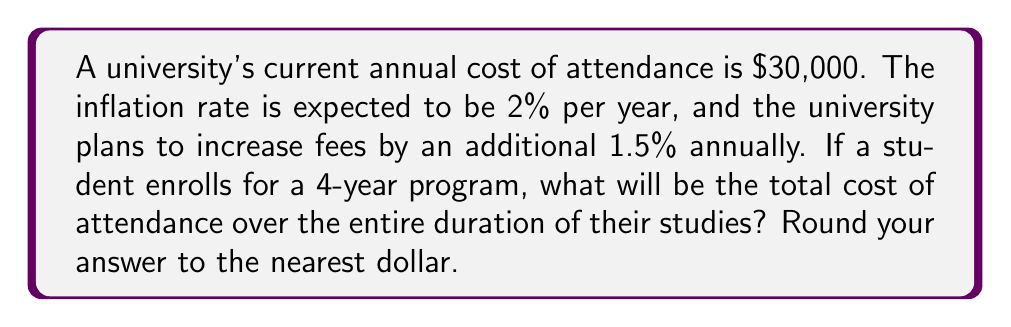Help me with this question. Let's approach this step-by-step:

1) First, we need to calculate the cost for each year, considering both inflation and fee increases. The total increase per year is 2% + 1.5% = 3.5%.

2) Let's define a function for the cost of attendance in year $n$:
   $$C(n) = 30000 \cdot (1.035)^n$$
   where $n$ is the number of years since the start (0 for first year, 1 for second year, etc.)

3) Now, we need to sum this function for $n = 0$ to $3$ to get the total cost over 4 years:
   $$\text{Total Cost} = \sum_{n=0}^3 C(n) = \sum_{n=0}^3 30000 \cdot (1.035)^n$$

4) Let's calculate each year's cost:
   Year 1 (n = 0): $30000 \cdot (1.035)^0 = 30000$
   Year 2 (n = 1): $30000 \cdot (1.035)^1 = 31050$
   Year 3 (n = 2): $30000 \cdot (1.035)^2 = 32136.75$
   Year 4 (n = 3): $30000 \cdot (1.035)^3 = 33261.53$

5) Sum these costs:
   $$\text{Total Cost} = 30000 + 31050 + 32136.75 + 33261.53 = 126448.28$$

6) Rounding to the nearest dollar gives us $126,448.
Answer: $126,448 